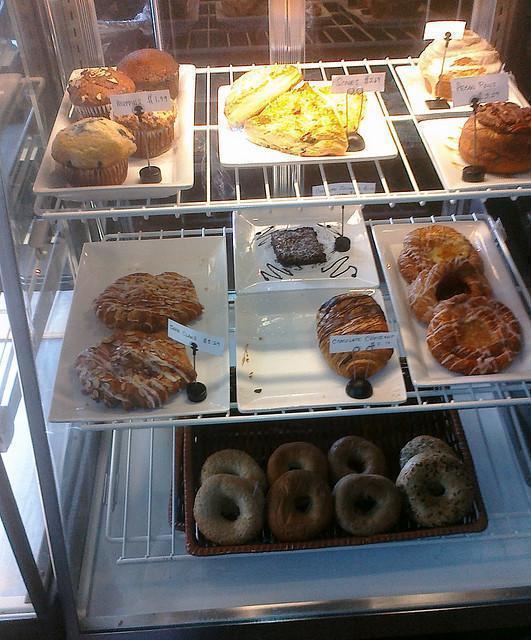What type of Danish is in the middle of the other two?
Choose the right answer and clarify with the format: 'Answer: answer
Rationale: rationale.'
Options: Cheese, peach, strawberry, blueberry. Answer: blueberry.
Rationale: The danish is blueberry. 